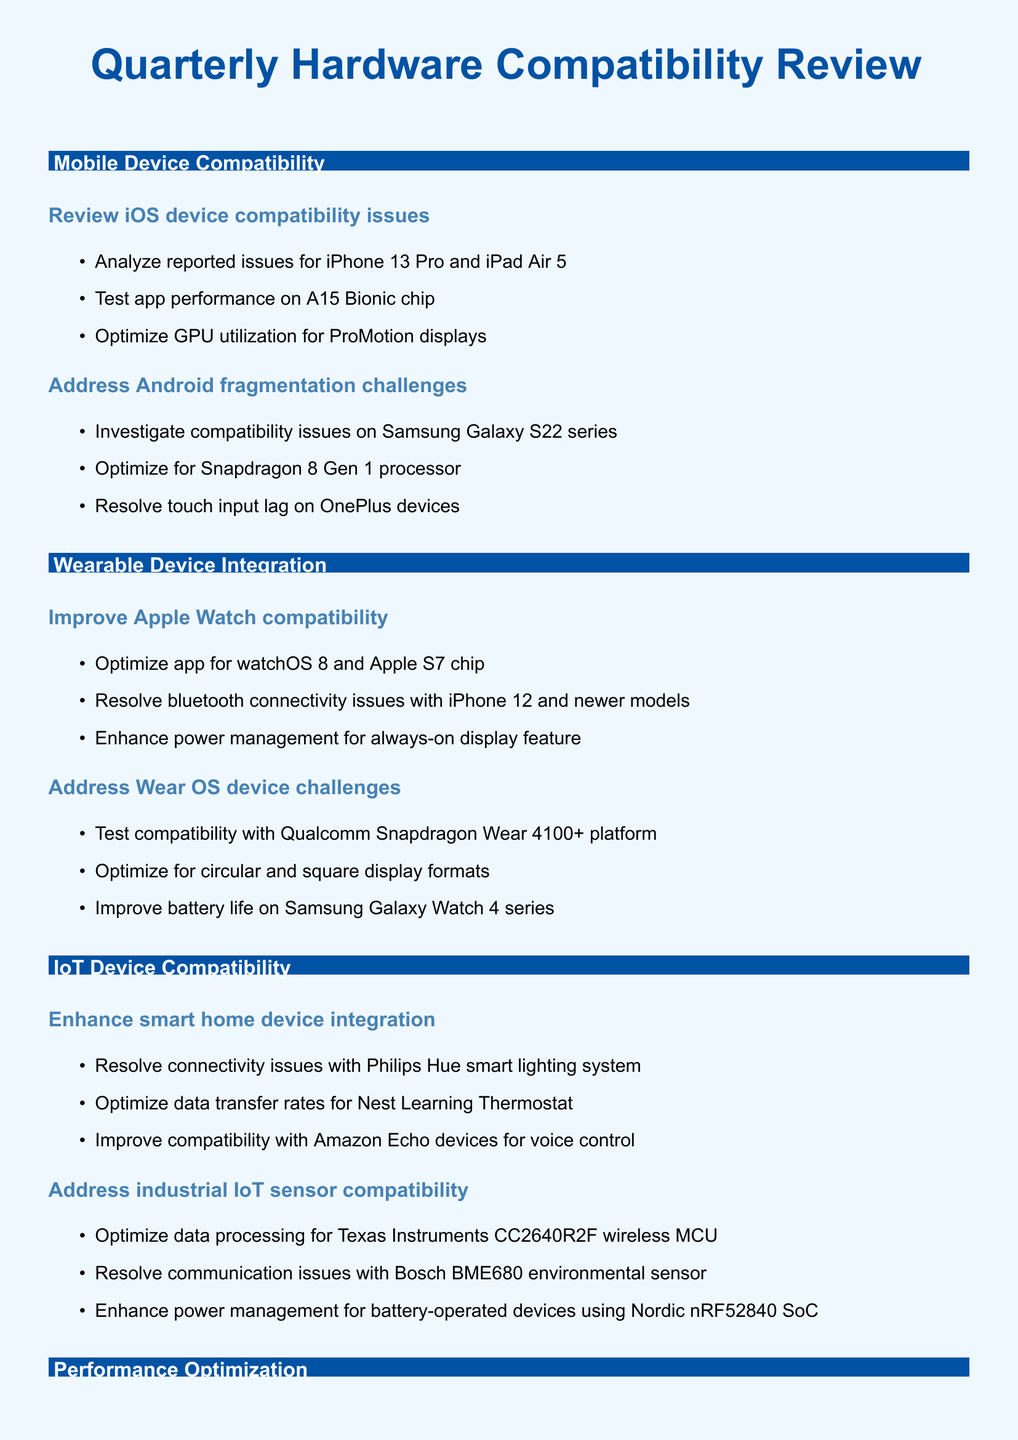What is the first mobile device compatibility task? The first task in the mobile device compatibility section is to review iOS device compatibility issues.
Answer: Review iOS device compatibility issues How many subtasks are there under the optimization for the Snapdragon 8 Gen 1 processor? There are three subtasks listed under the task addressing Android fragmentation challenges.
Answer: Three What is the main focus of the wearable device integration section? The main focus is on improving compatibility with Apple Watch and addressing challenges with Wear OS devices.
Answer: Improve Apple Watch compatibility and address Wear OS device challenges What specific smart home device is mentioned for connectivity issues? The document lists Philips Hue smart lighting system as an example of a smart home device with connectivity issues.
Answer: Philips Hue smart lighting system Which processor is mentioned in the performance optimization tasks? The document mentions optimizing multithreading for the Qualcomm Snapdragon 888 octa-core processor.
Answer: Qualcomm Snapdragon 888 How many tasks are there in the section on hardware-specific feature implementation? There are two tasks in this section: implementing new sensor capabilities and enhancing camera integration.
Answer: Two What is the target device for improving low-light performance? The target device for improving low-light performance is the Google Pixel 6 Pro.
Answer: Google Pixel 6 Pro What type of chip does the Apple Watch optimization focus on? The optimization focuses on the Apple S7 chip.
Answer: Apple S7 chip Which platform is mentioned for testing Wear OS device challenges? The platform mentioned for testing is the Qualcomm Snapdragon Wear 4100+ platform.
Answer: Qualcomm Snapdragon Wear 4100+ 